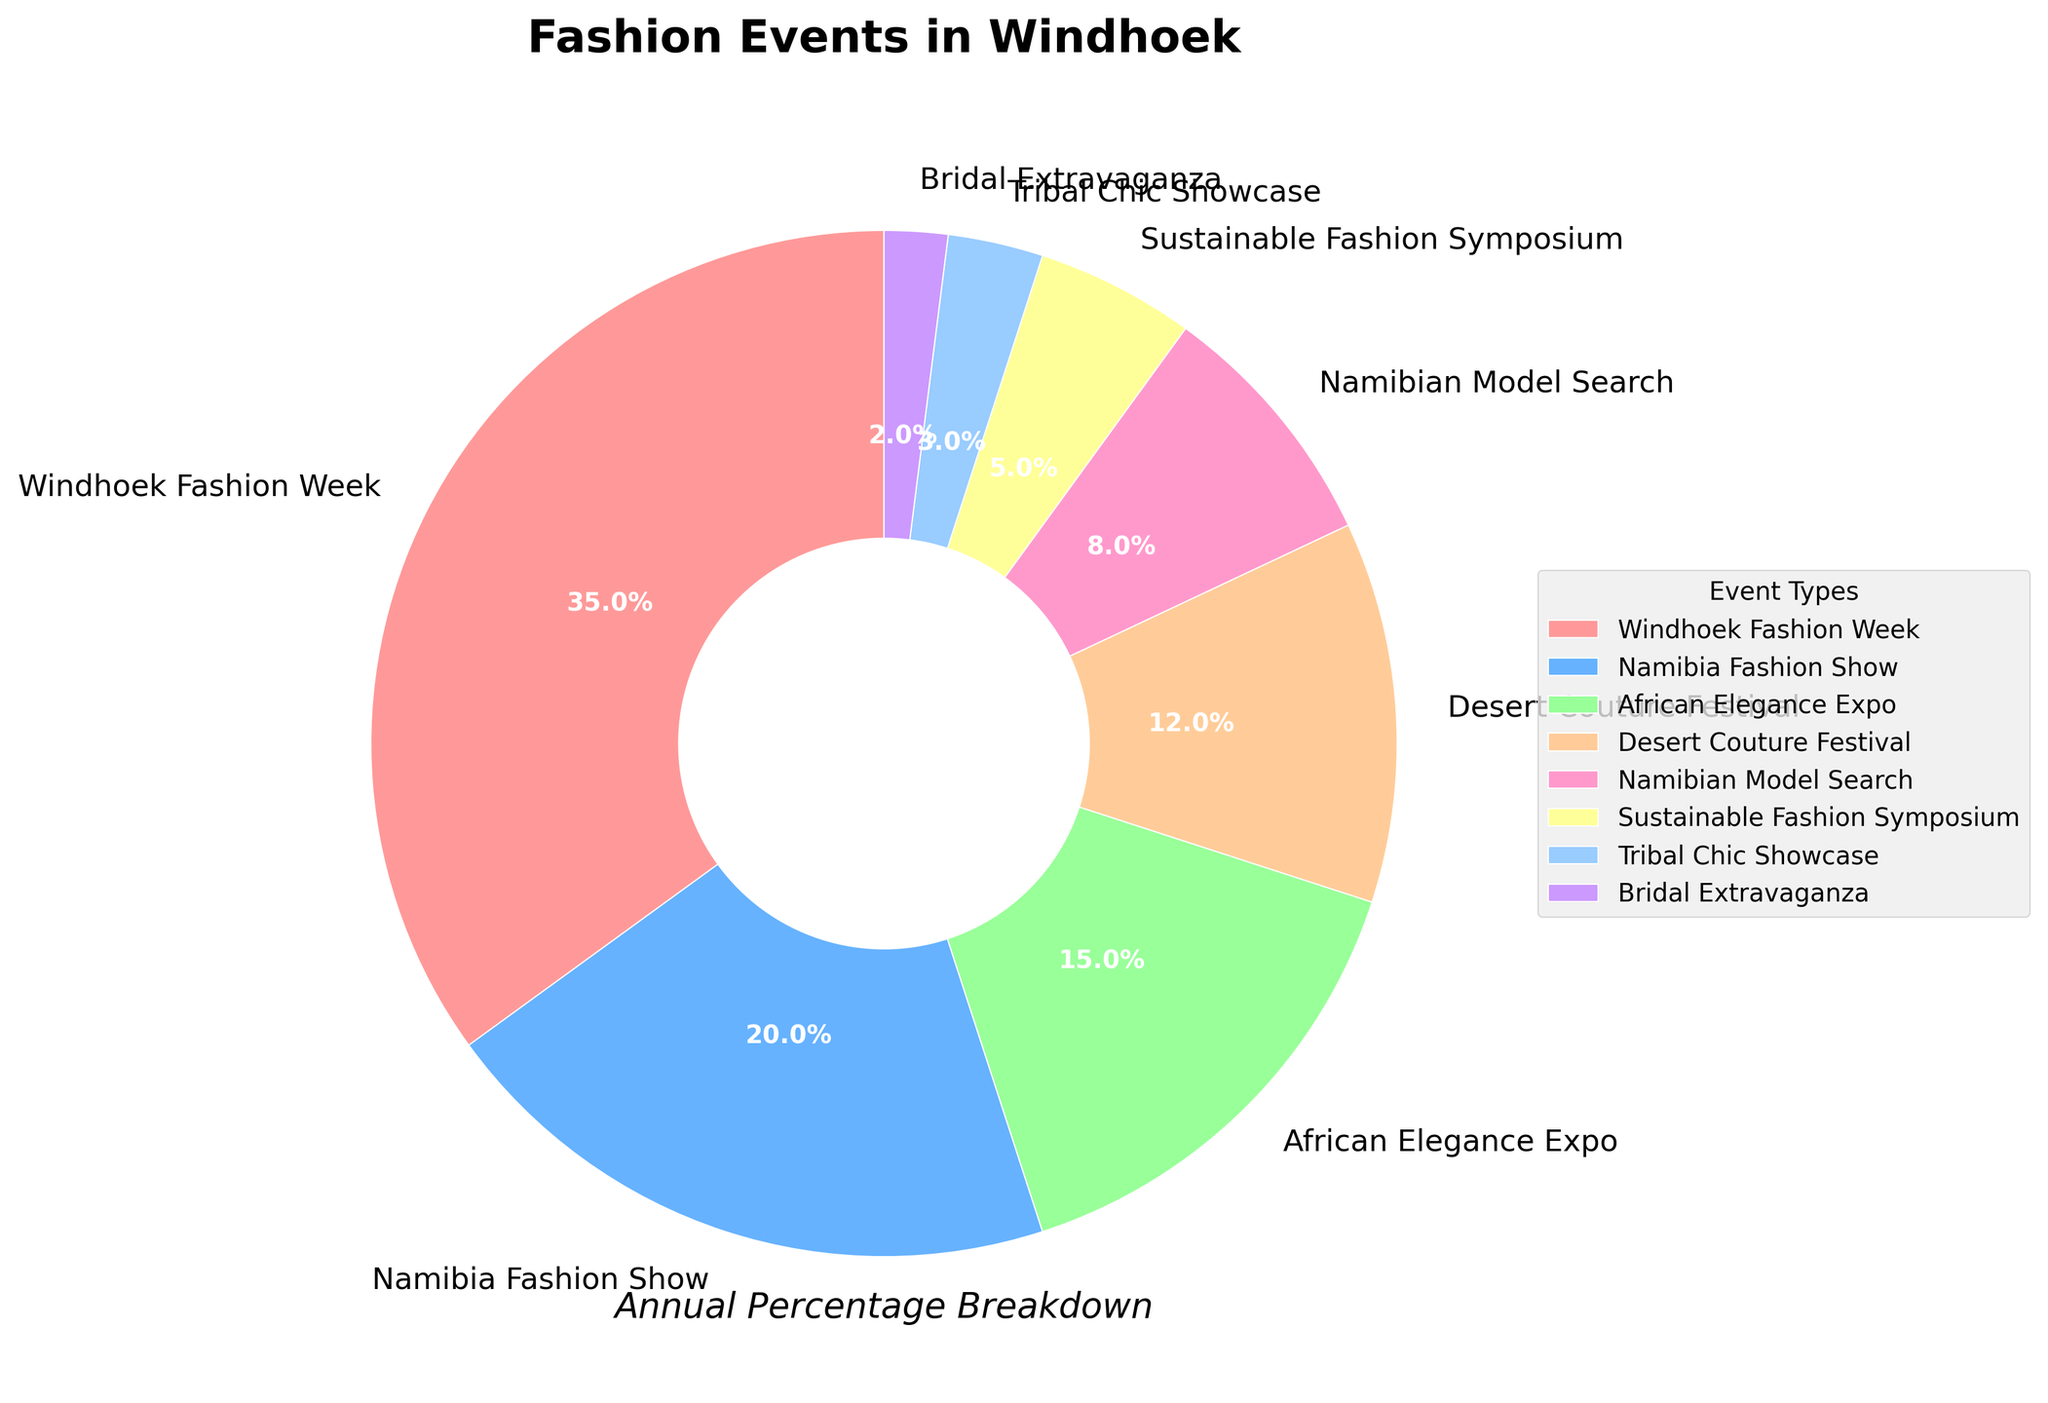Which event has the highest percentage? By observing the figure, you will notice which section of the pie chart takes up the largest area, representing 35%. This corresponds to "Windhoek Fashion Week".
Answer: Windhoek Fashion Week Which two events have a combined percentage of more than 50%? You can see two largest segments: "Windhoek Fashion Week" (35%) and "Namibia Fashion Show" (20%). Adding them together gives 35% + 20% = 55%, which is more than 50%.
Answer: Windhoek Fashion Week and Namibia Fashion Show Which event has the smallest percentage? The pie chart has a tiny segment with a 2% label. This segment corresponds to the "Bridal Extravaganza".
Answer: Bridal Extravaganza What is the total percentage contribution of the African Elegance Expo and Desert Couture Festival? Locate the segments labeled "African Elegance Expo" (15%) and "Desert Couture Festival" (12%), then add them together: 15% + 12% = 27%.
Answer: 27% How many events have percentages in single digits? Check the number of segments with percentages under 10%. These events are "Namibian Model Search" (8%), "Sustainable Fashion Symposium" (5%), "Tribal Chic Showcase" (3%), and "Bridal Extravaganza" (2%)—a total of 4 events.
Answer: 4 Which events combined represent approximately 50% of the total? Examine the segments until their combined percentage approximates 50%. "Windhoek Fashion Week" (35%) and "Namibia Fashion Show" (20%) together make 55%, which is close to 50%.
Answer: Windhoek Fashion Week and Namibia Fashion Show What percentage breakdown other than Windhoek Fashion Week receives the top three highest percentages? Exclude "Windhoek Fashion Week" (35%) and look for the next three highest segments: "Namibia Fashion Show" (20%), "African Elegance Expo" (15%), and "Desert Couture Festival" (12%). Add these percentages: 20% + 15% + 12% = 47%.
Answer: 47% How do the lowest three percentages compare to the highest percentage? Identify the smallest three events: "Bridal Extravaganza" (2%), "Tribal Chic Showcase" (3%), and "Sustainable Fashion Symposium" (5%). Add them together: 2% + 3% + 5% = 10%. Compare this sum to the highest percentage, 35%.
Answer: Lowest three percentages (10%) < Highest percentage (35%) What would the percentage be if the Desert Couture Festival is combined with the Namibian Model Search? Identify their percentages: "Desert Couture Festival" (12%) and "Namibian Model Search" (8%). Their combined percentage is 12% + 8% = 20%.
Answer: 20% How much more does Windhoek Fashion Week contribute than the combined Tribal Chic Showcase and Bridal Extravaganza? Identify "Tribal Chic Showcase" (3%) and "Bridal Extravaganza" (2%). Their combined percentage: 3% + 2% = 5%. Windhoek Fashion Week's percentage minus this combined percentage: 35% - 5% = 30%.
Answer: 30% 